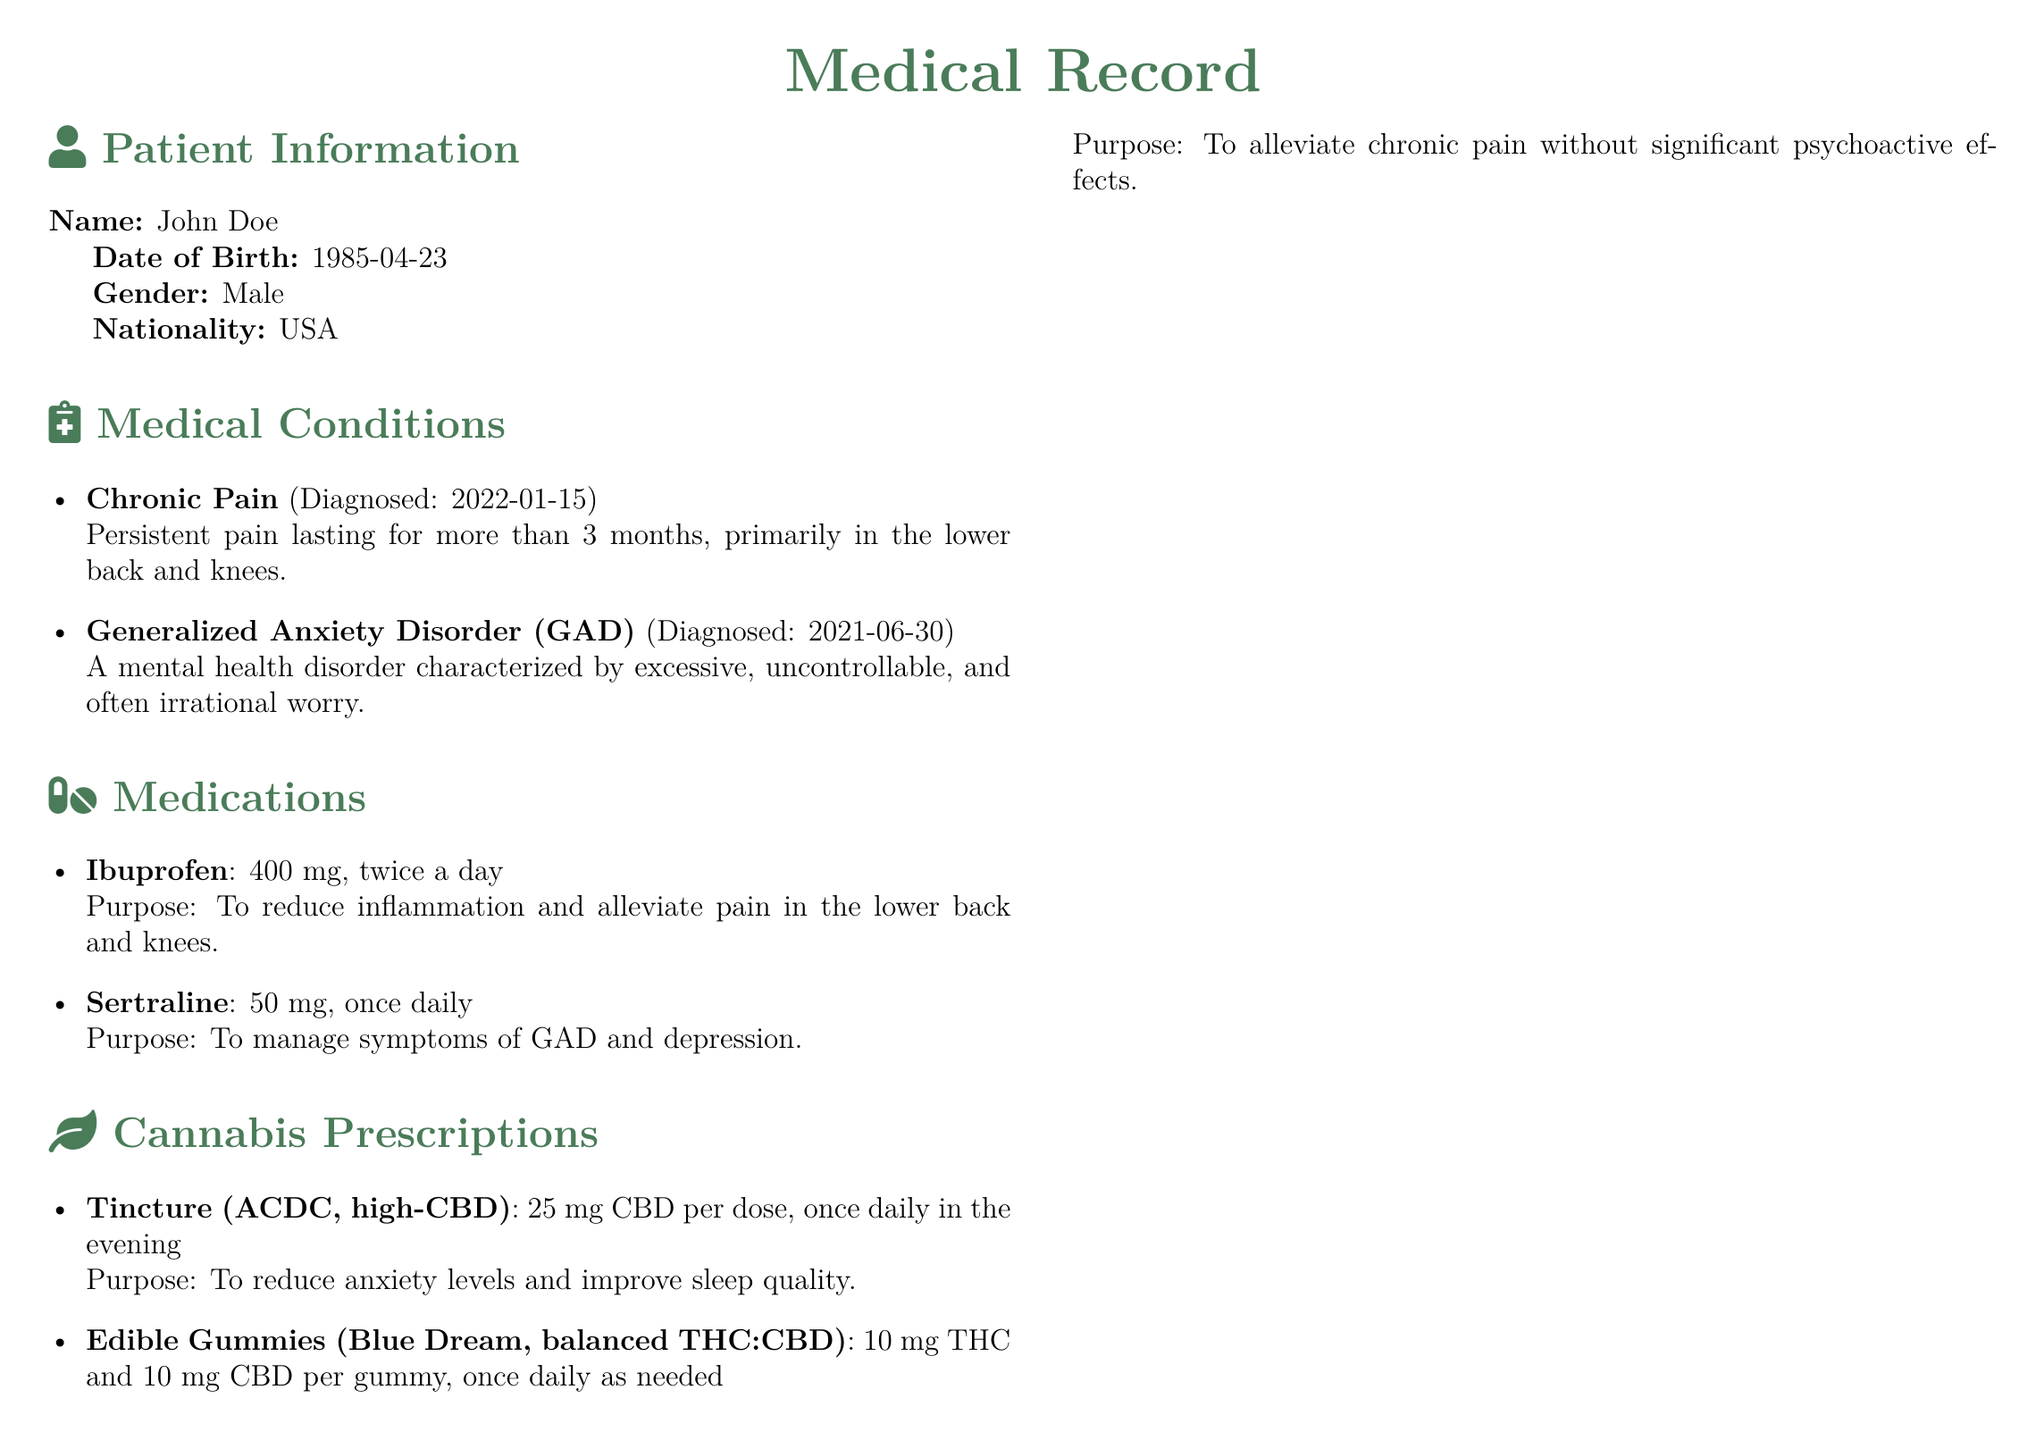what is the patient's name? The patient's name is clearly stated in the document under Patient Information.
Answer: John Doe what is the dosage of Ibuprofen? The document specifies the dosage of Ibuprofen in the Medications section.
Answer: 400 mg, twice a day when was the patient diagnosed with Chronic Pain? The diagnosis date for Chronic Pain is mentioned in the Medical Conditions section.
Answer: 2022-01-15 what is the purpose of the ACDC tincture? The document outlines the purpose of each cannabis prescription in the Cannabis Prescriptions section.
Answer: To reduce anxiety levels and improve sleep quality how often can the edible gummies be used? The usage frequency for the edible gummies is detailed in the Cannabis Prescriptions section.
Answer: Once daily as needed what health precaution is advised in the Travel Advisory? The Travel Advisory section provides health precautions regarding cannabis use.
Answer: Hydrate frequently to avoid dehydration which clinic in Amsterdam did the patient visit? The document states the clinics the patient visited, including location information.
Answer: Wellness Clinic how many medical conditions does the patient have? The number of medical conditions is listed in the Medical Conditions section.
Answer: Two 